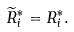Convert formula to latex. <formula><loc_0><loc_0><loc_500><loc_500>\widetilde { R } _ { i } ^ { * } = R _ { i } ^ { * } .</formula> 